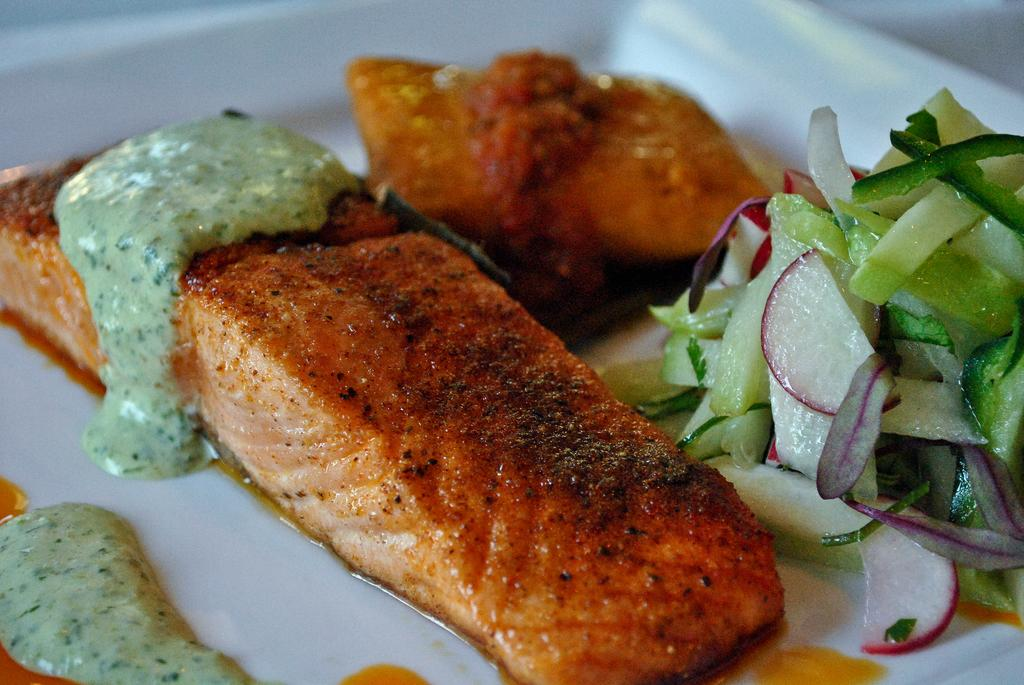What is the main object in the image? There is a dish in the image. How is the dish presented? The dish is served in a plate. Can you tell me how many rivers are flowing through the dish in the image? There are no rivers present in the image; it features a dish served in a plate. What type of society is depicted in the image? There is no society depicted in the image; it only shows a dish served in a plate. 